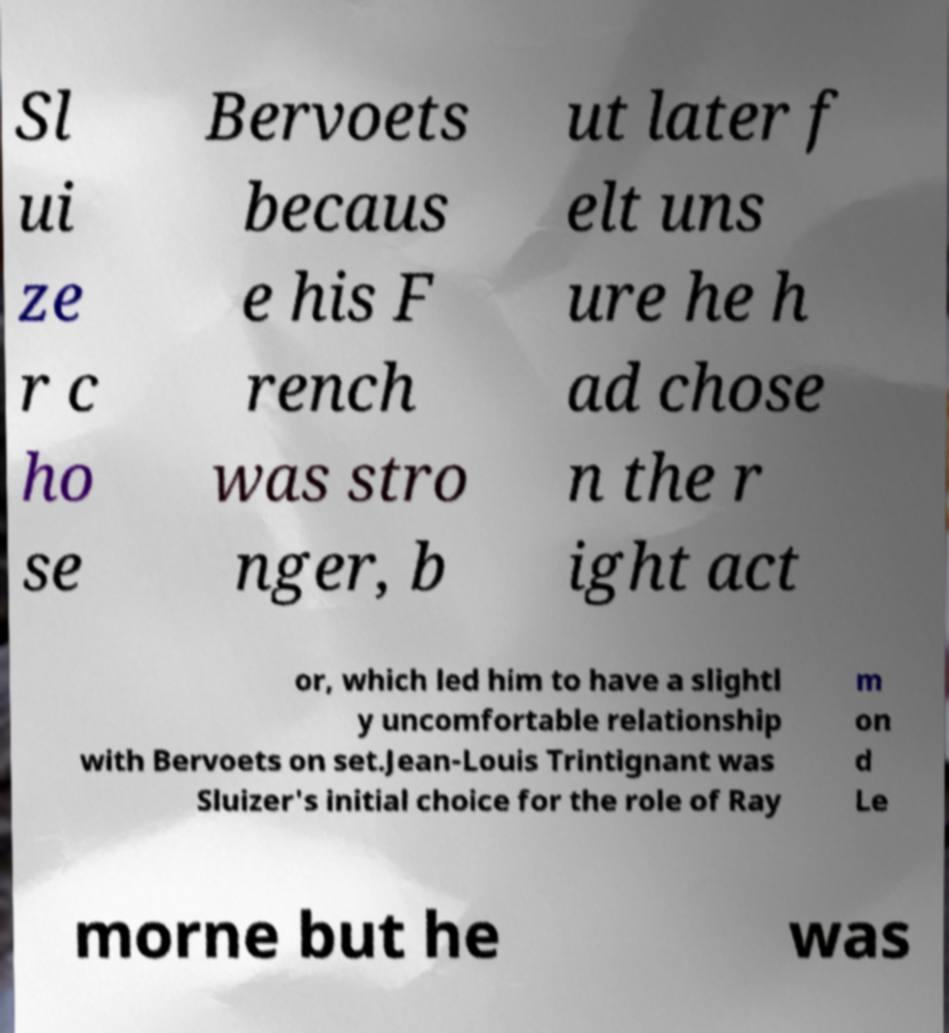For documentation purposes, I need the text within this image transcribed. Could you provide that? Sl ui ze r c ho se Bervoets becaus e his F rench was stro nger, b ut later f elt uns ure he h ad chose n the r ight act or, which led him to have a slightl y uncomfortable relationship with Bervoets on set.Jean-Louis Trintignant was Sluizer's initial choice for the role of Ray m on d Le morne but he was 